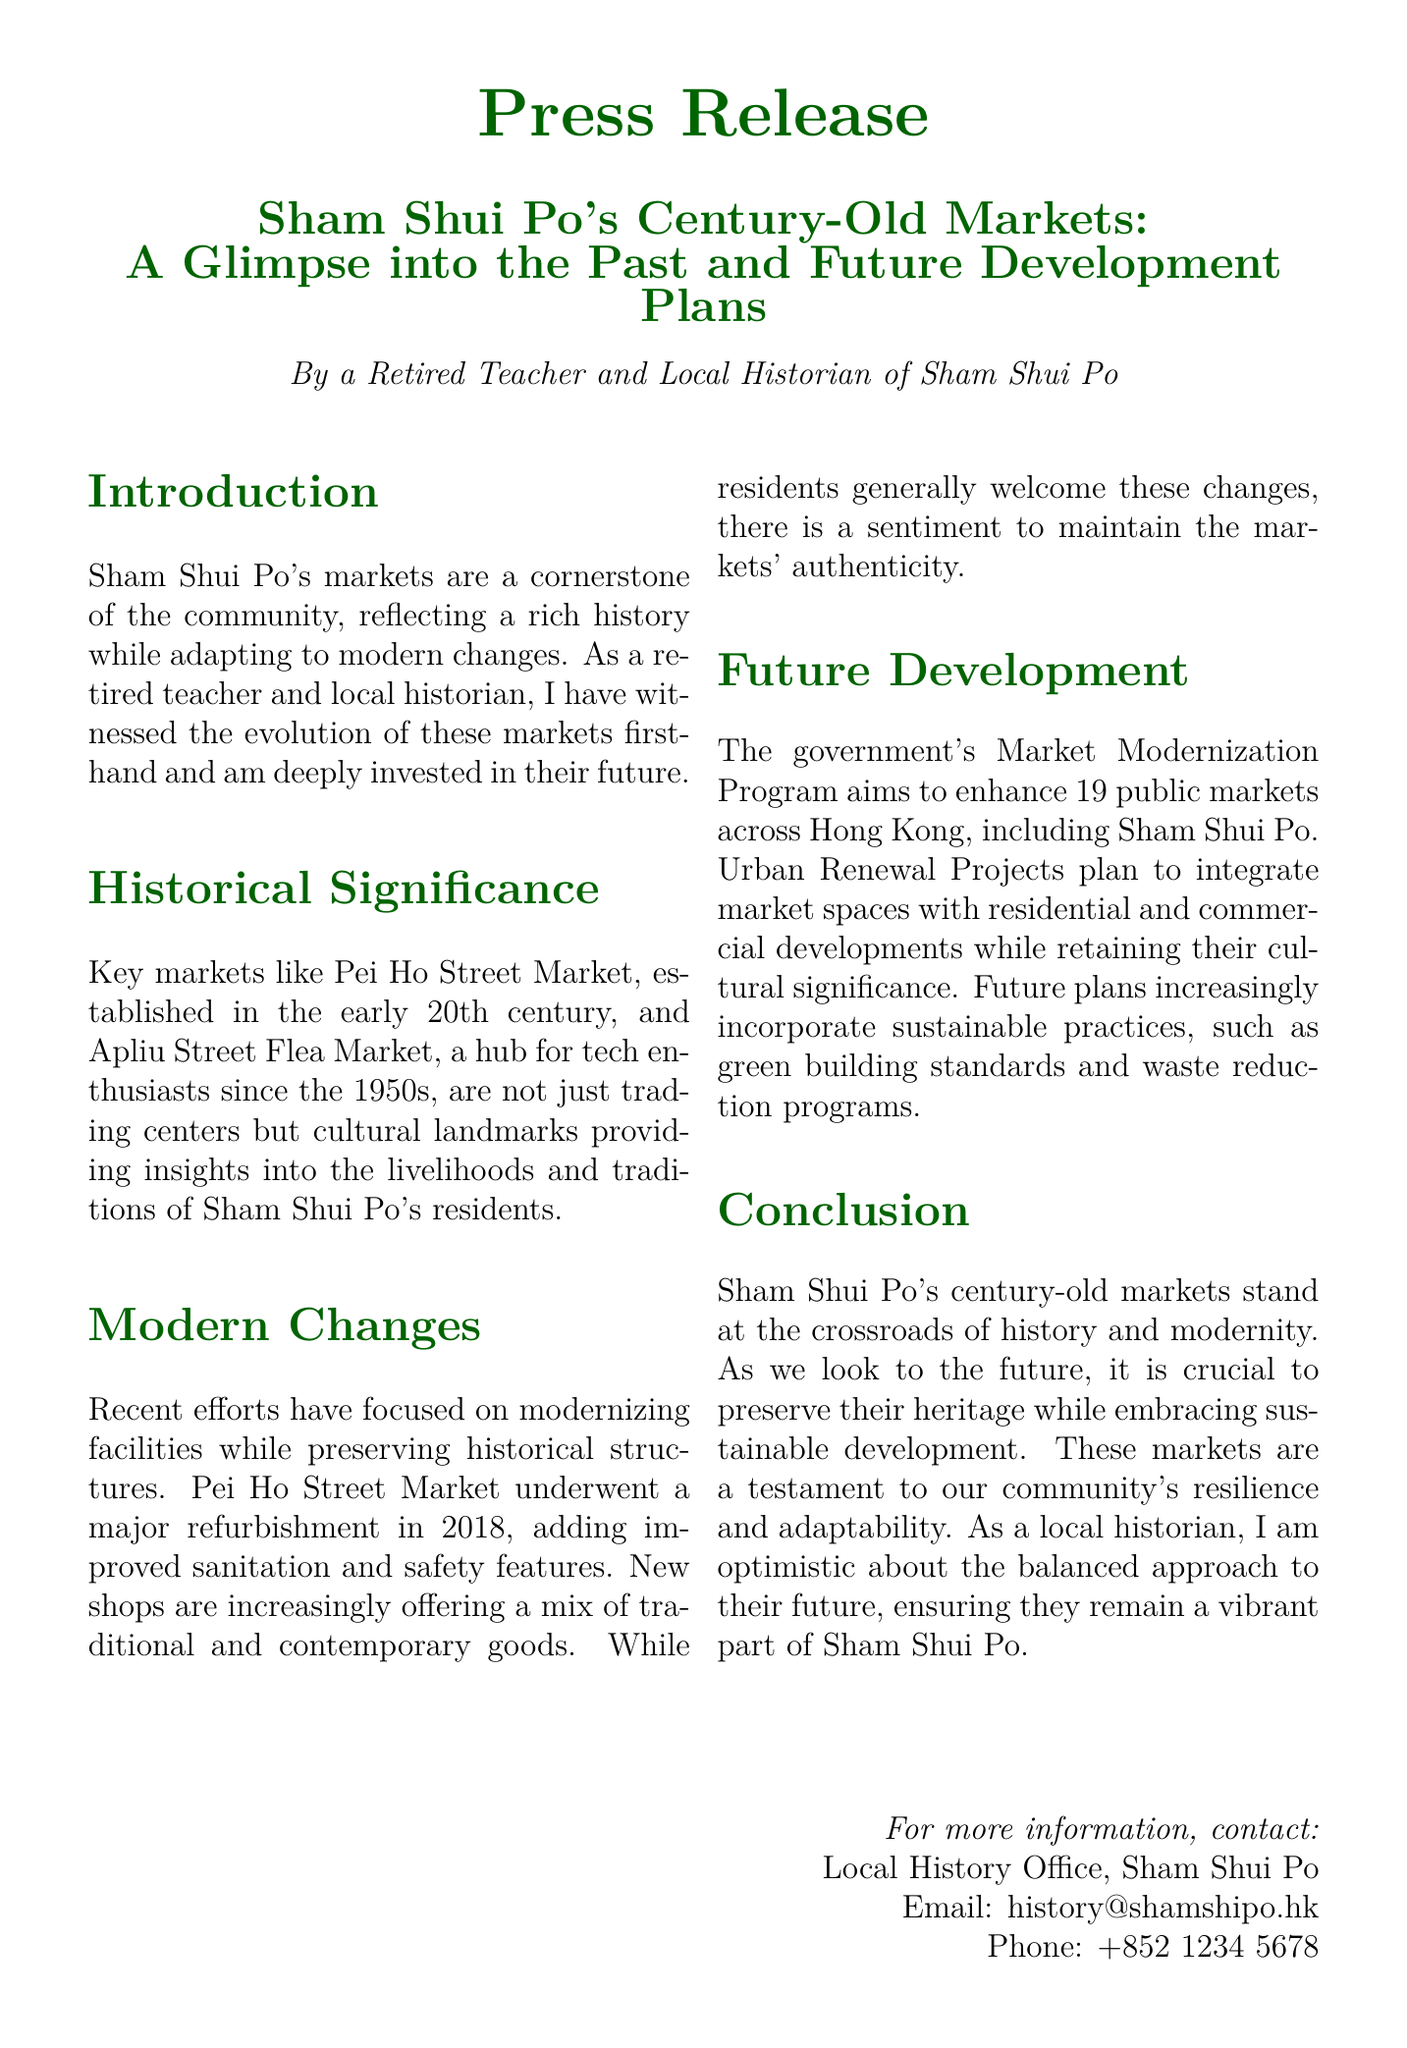What is the title of the press release? The title provides the main topic and focus of the document, which is the historical significance and future plans for Sham Shui Po's markets.
Answer: Sham Shui Po's Century-Old Markets: A Glimpse into the Past and Future Development Plans When was Pei Ho Street Market established? The document mentions the early 20th century as the time of establishment for Pei Ho Street Market.
Answer: early 20th century What major refurbishment took place in 2018? The refurbishment of Pei Ho Street Market is highlighted in the document, emphasizing improvements added during that year.
Answer: Pei Ho Street Market How many public markets will the Market Modernization Program enhance? The document states that the program aims to enhance multiple public markets in Hong Kong, specifically mentioning 19 markets.
Answer: 19 What initiative focuses on maintaining the authenticity of the markets? The document discusses community sentiments around modern changes, emphasizing the importance of retaining the markets' authenticity.
Answer: community sentiments Which two markets are mentioned as key examples? Key markets in Sham Shui Po are specifically named in the document, showcasing their significance and history.
Answer: Pei Ho Street Market, Apliu Street Flea Market What type of standards are future plans incorporating? The document references sustainable practices in future development plans, particularly about building requirements.
Answer: green building standards What is the role of the Local History Office in relation to the press release? The document lists the contact information for the Local History Office, indicating its role in providing information on local history.
Answer: information provider 